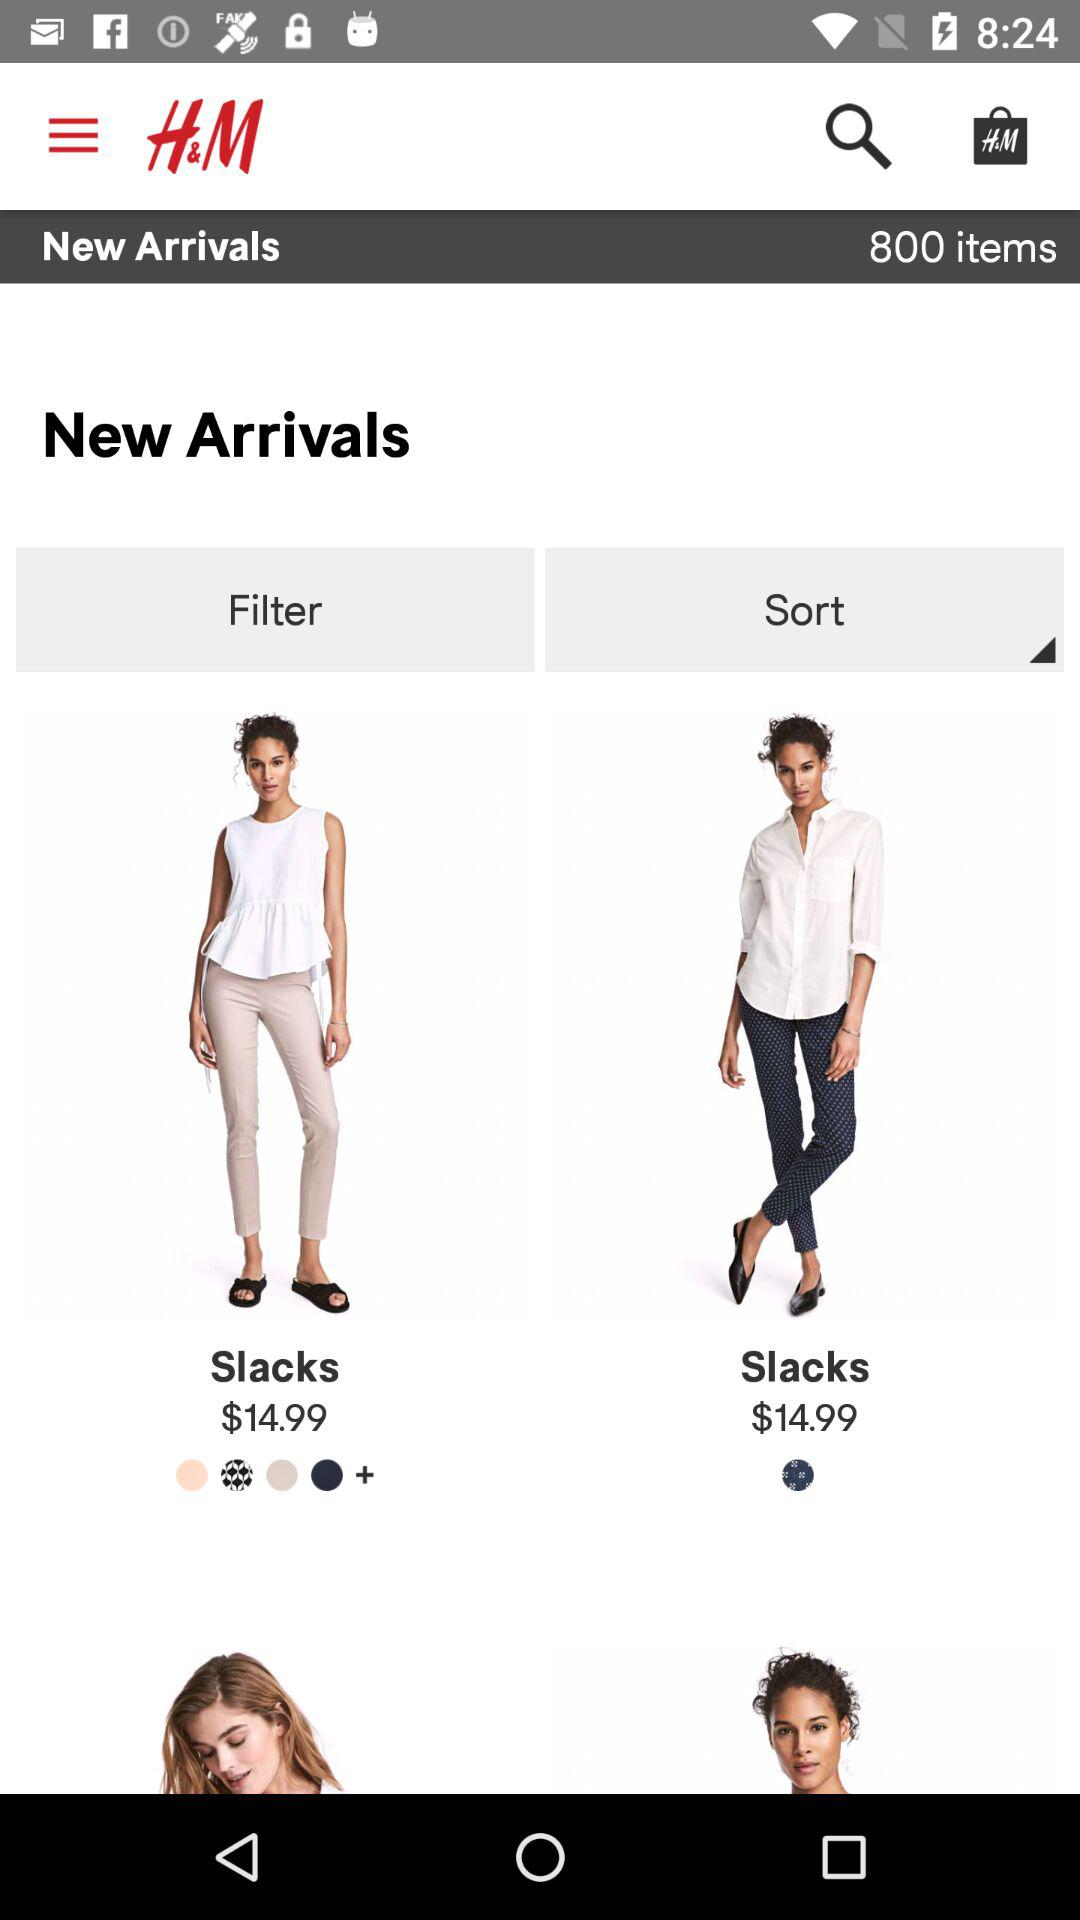How many items are there in total?
Answer the question using a single word or phrase. 800 